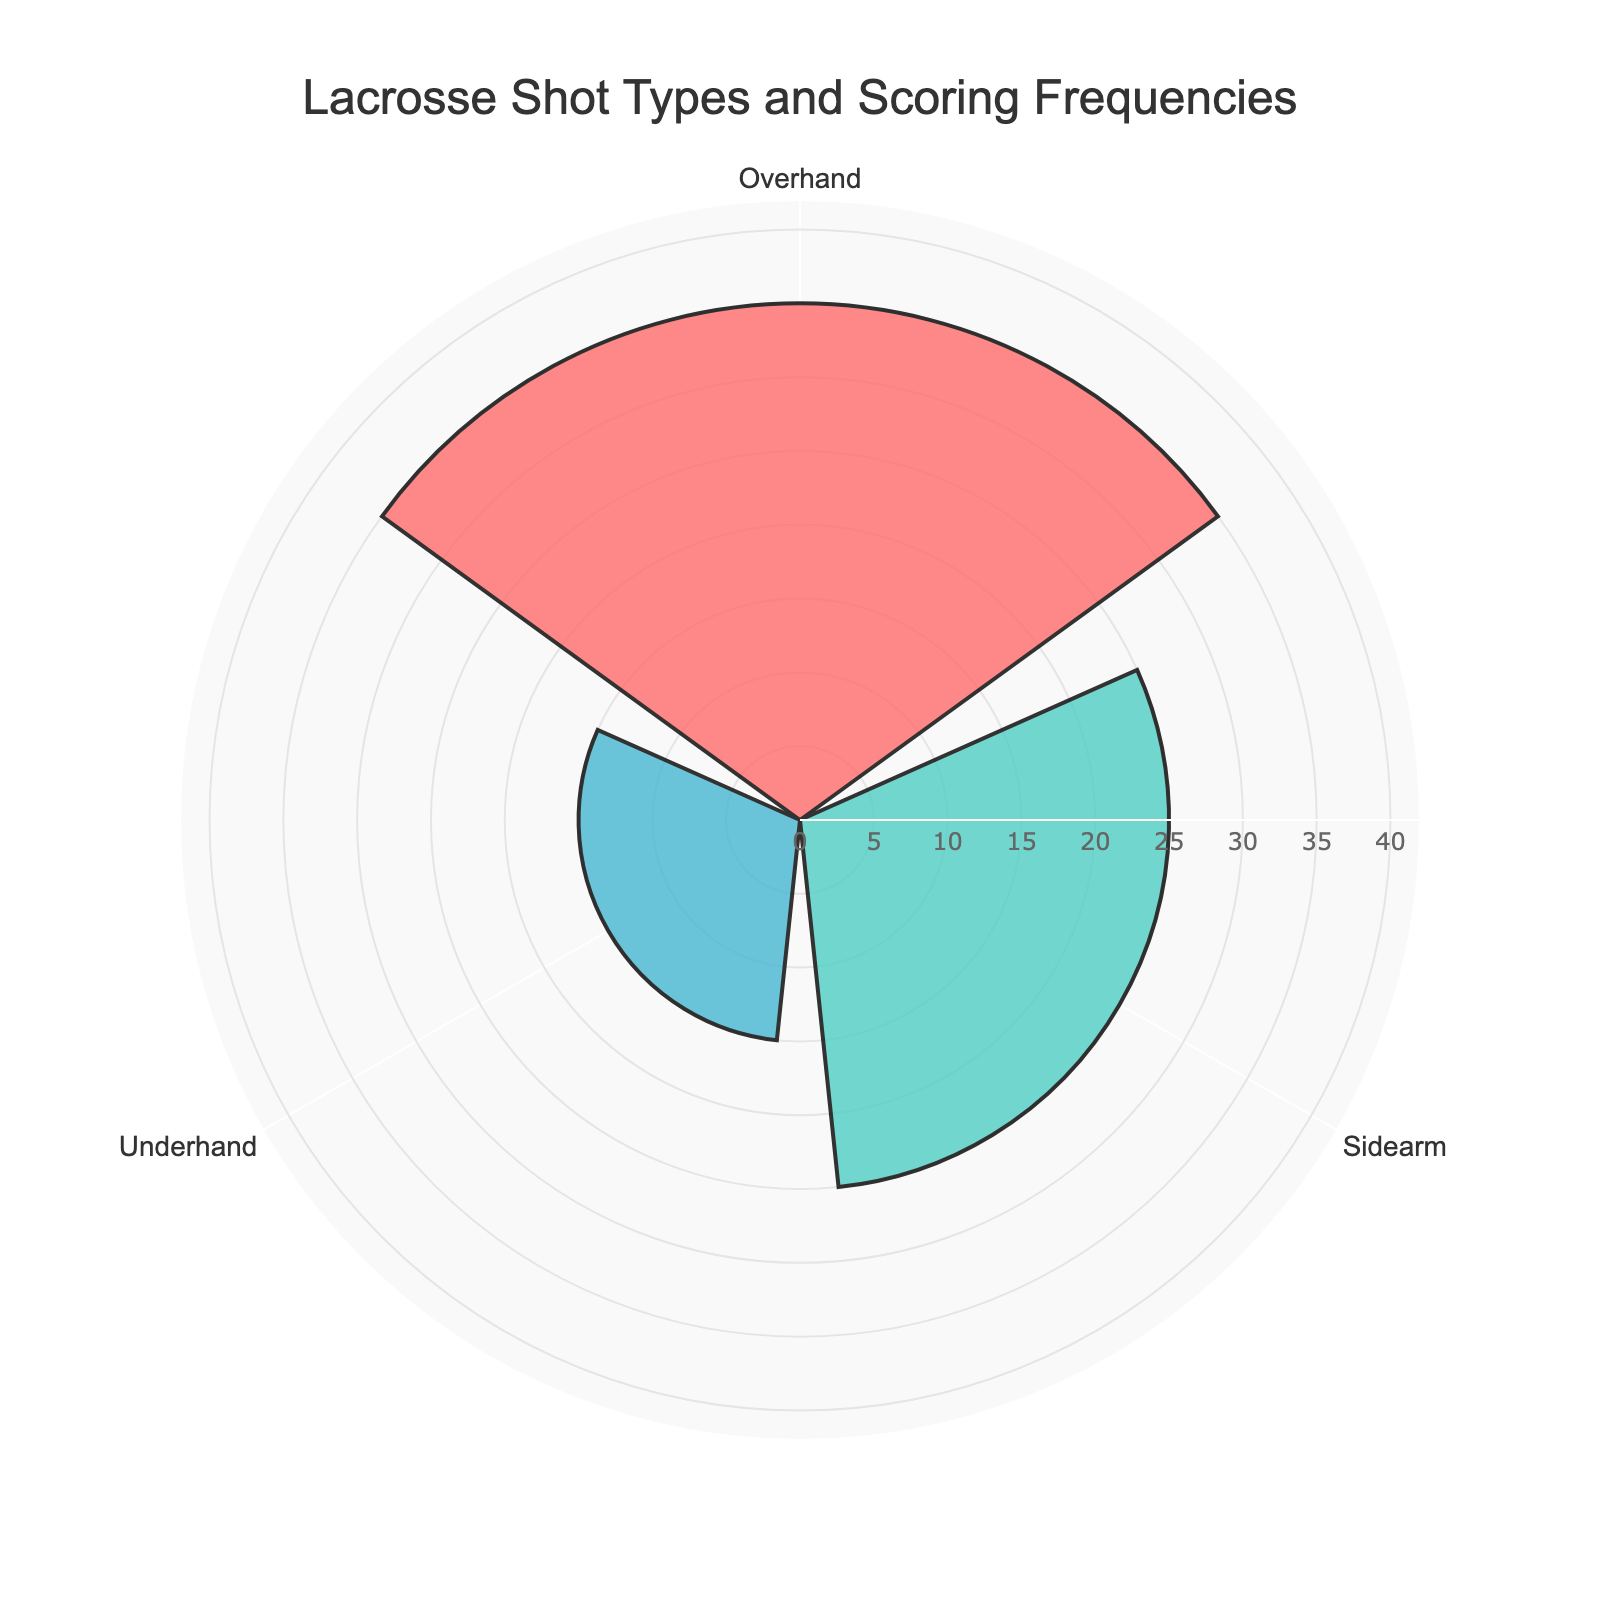What's the title of the figure? The title is usually placed prominently at the top or center of the figure. It helps to summarize the main subject being visualized.
Answer: Lacrosse Shot Types and Scoring Frequencies How many types of lacrosse shots are displayed in the chart? By observing the distinct labels on the chart, we can count the number of different shot types.
Answer: 3 Which type of shot has the highest frequency? Identify the highest bar or sector in the rose chart, which corresponds to the shot type with the highest value.
Answer: Overhand What is the frequency difference between Overhand and Underhand shots? Look for the frequency values of Overhand (35) and Underhand (15). Subtract the smaller value from the larger one: 35 - 15.
Answer: 20 What is the average frequency of the three shot types? Sum the frequencies of all shot types (35 + 25 + 15) and divide by the number of shot types (3): (35 + 25 + 15) / 3.
Answer: 25 Which shot type has the lowest scoring frequency? Identify the smallest bar or sector in the rose chart, which corresponds to the shot type with the lowest value.
Answer: Underhand How much more frequent is Sidearm compared to Underhand shots? Subtract the frequency of Underhand shots (15) from Sidearm shots (25): 25 - 15.
Answer: 10 What is the combined frequency of Overhand and Sidearm shots? Add the frequencies of Overhand (35) and Sidearm (25): 35 + 25.
Answer: 60 How does the frequency of Sidearm shots compare to the average frequency of all shots? Calculate the average frequency (25) and compare it with the Sidearm frequency (25). Both are equal.
Answer: It is equal In terms of frequency, rank the shot types from highest to lowest. List the shot types in descending order based on their frequencies: Overhand (35), Sidearm (25), Underhand (15).
Answer: Overhand, Sidearm, Underhand 